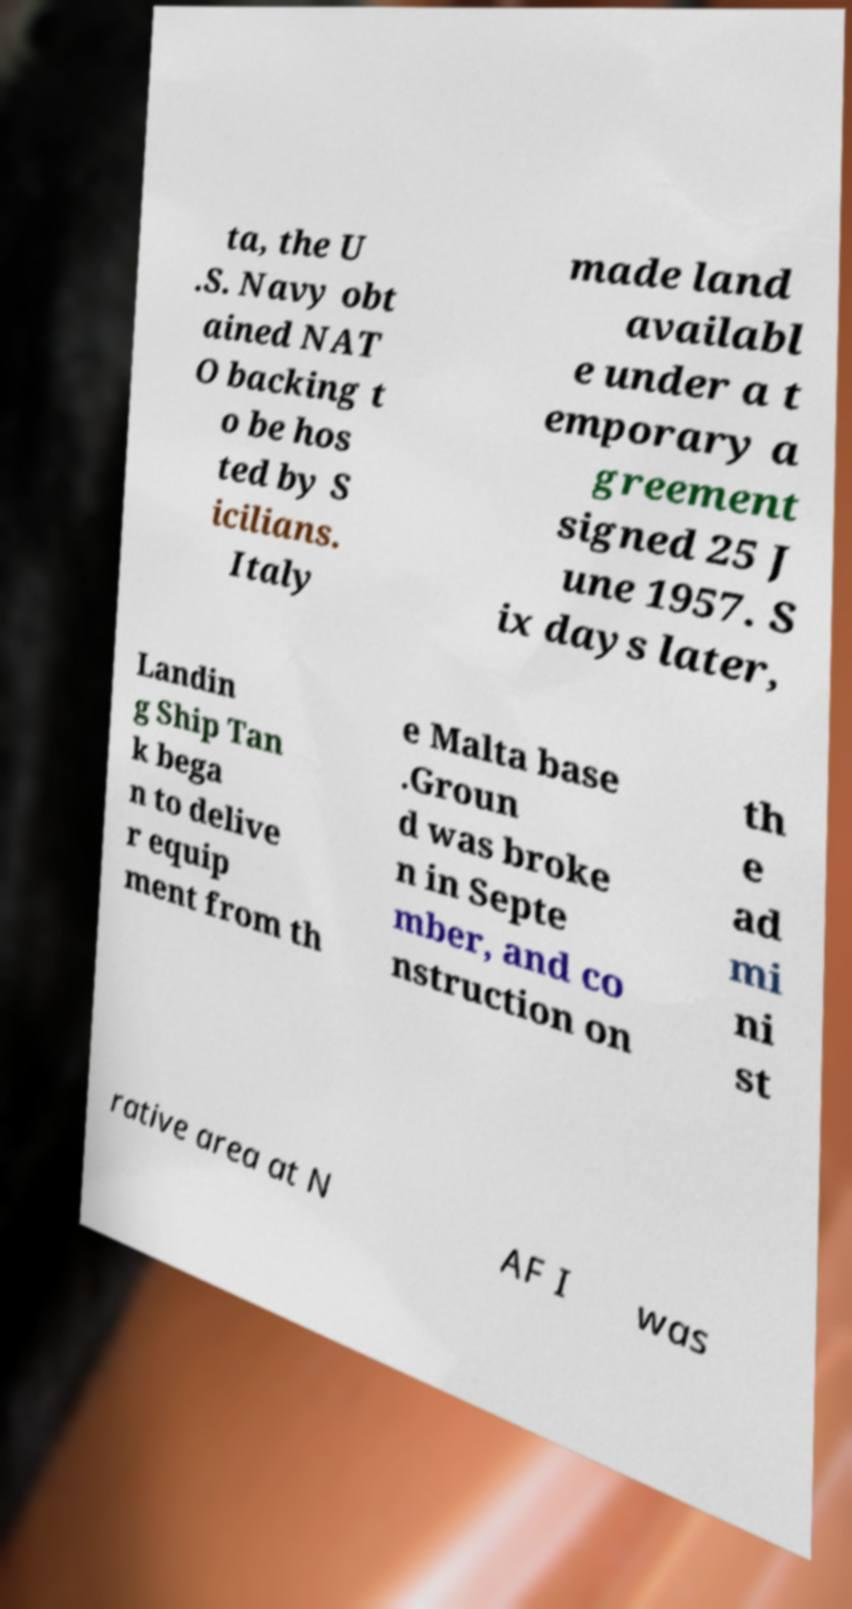There's text embedded in this image that I need extracted. Can you transcribe it verbatim? ta, the U .S. Navy obt ained NAT O backing t o be hos ted by S icilians. Italy made land availabl e under a t emporary a greement signed 25 J une 1957. S ix days later, Landin g Ship Tan k bega n to delive r equip ment from th e Malta base .Groun d was broke n in Septe mber, and co nstruction on th e ad mi ni st rative area at N AF I was 